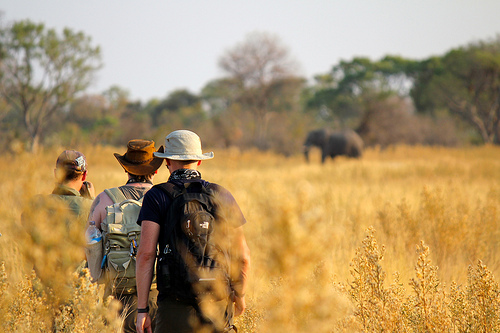Are there both elephants and polar bears in this photo? No, there are only elephants in this photo. 